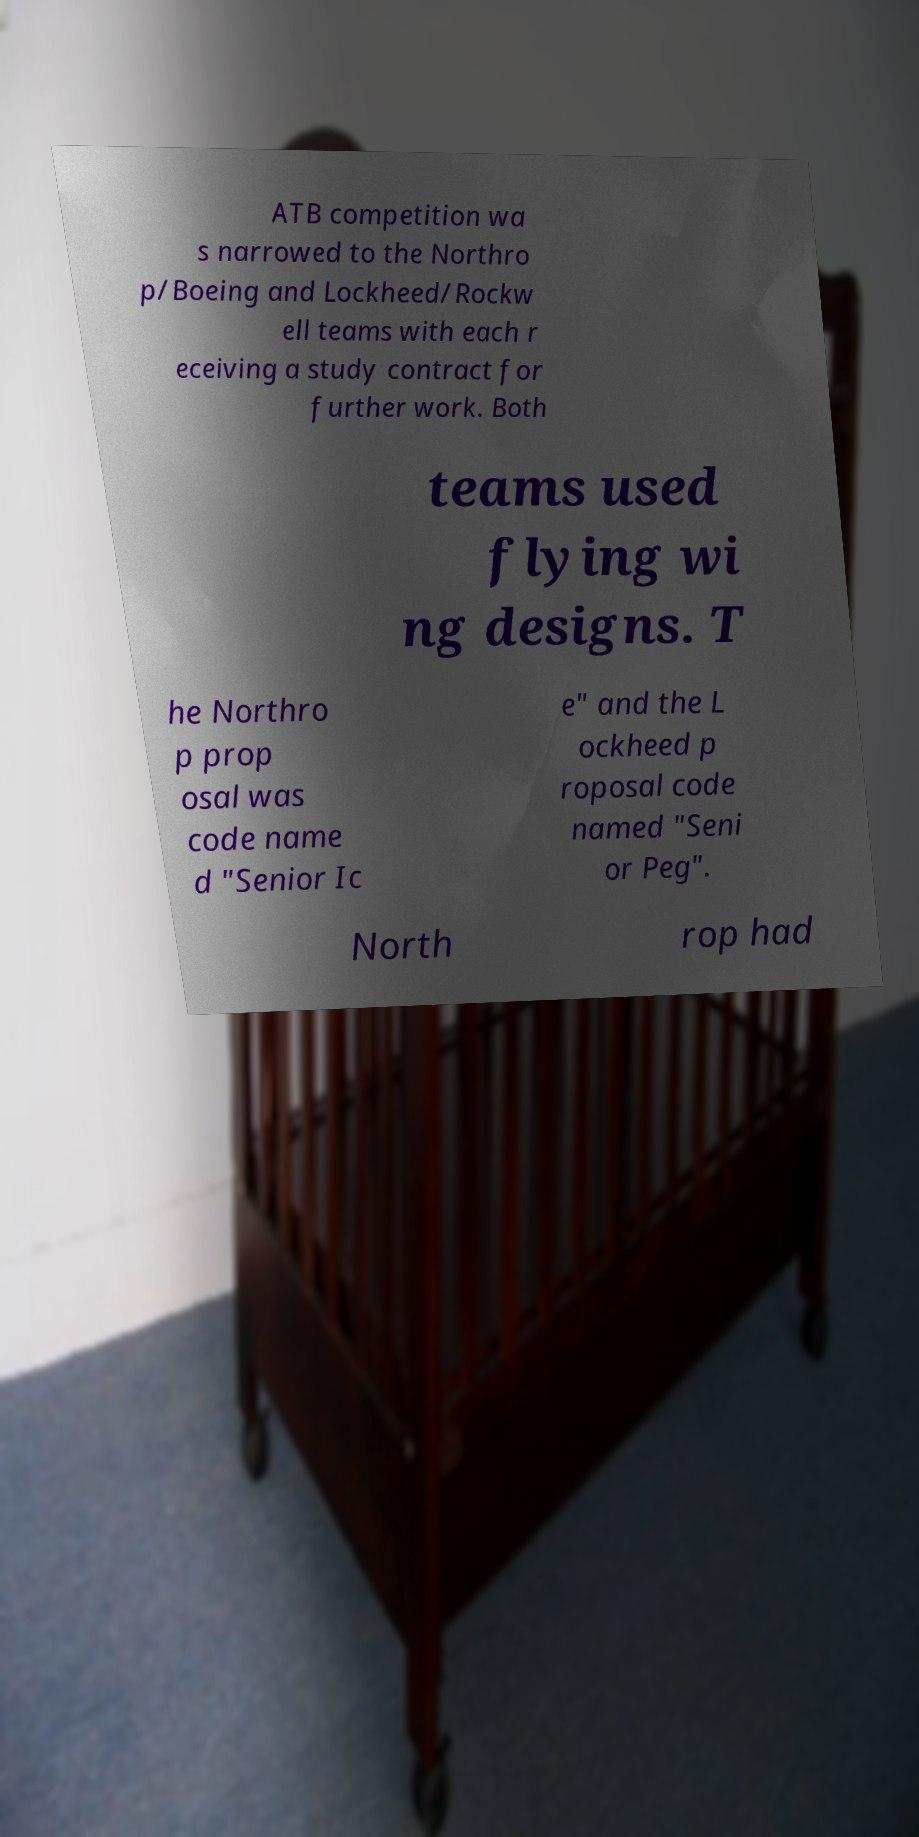Can you accurately transcribe the text from the provided image for me? ATB competition wa s narrowed to the Northro p/Boeing and Lockheed/Rockw ell teams with each r eceiving a study contract for further work. Both teams used flying wi ng designs. T he Northro p prop osal was code name d "Senior Ic e" and the L ockheed p roposal code named "Seni or Peg". North rop had 